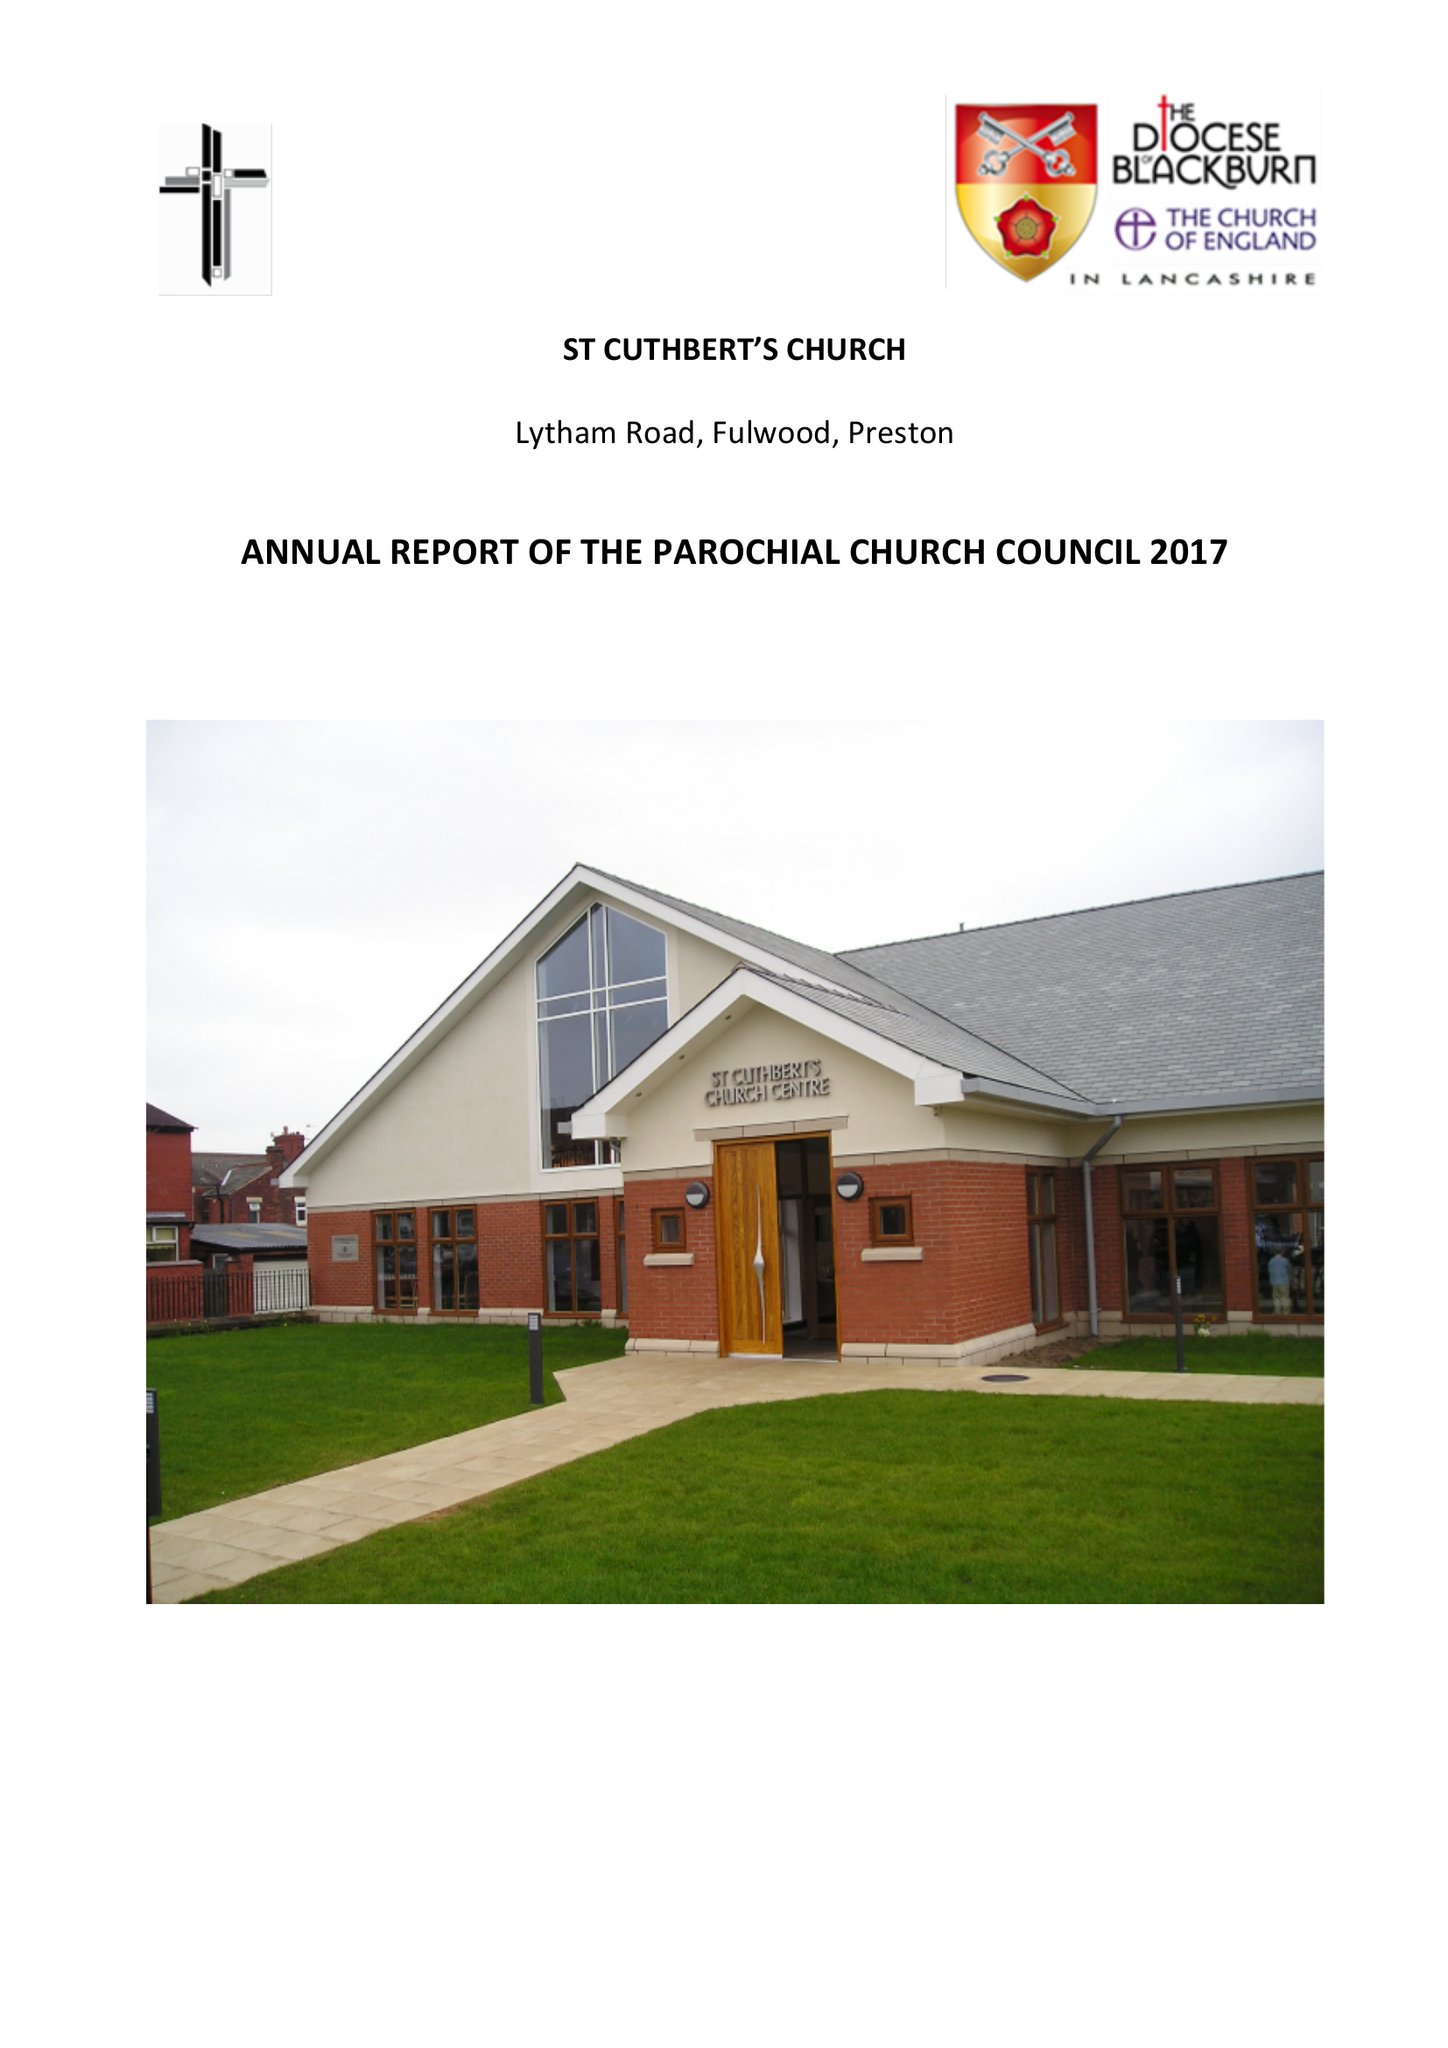What is the value for the address__post_town?
Answer the question using a single word or phrase. PRESTON 